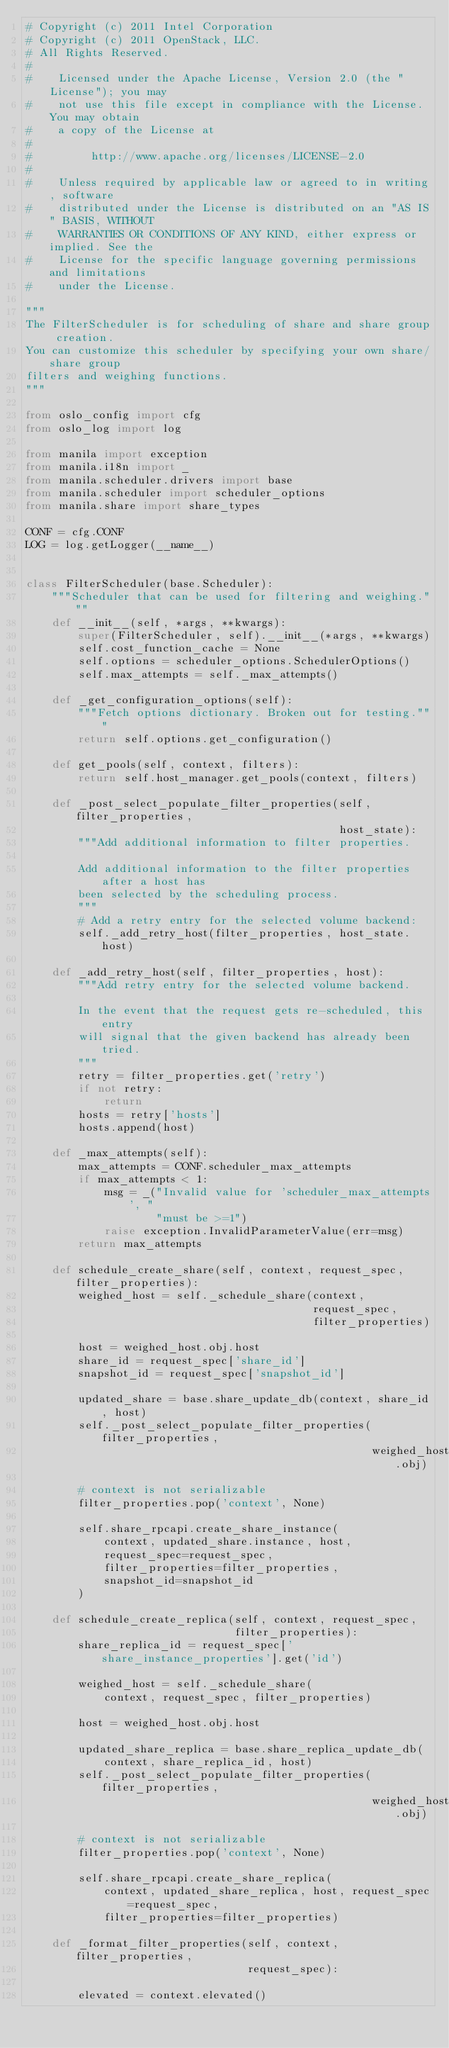Convert code to text. <code><loc_0><loc_0><loc_500><loc_500><_Python_># Copyright (c) 2011 Intel Corporation
# Copyright (c) 2011 OpenStack, LLC.
# All Rights Reserved.
#
#    Licensed under the Apache License, Version 2.0 (the "License"); you may
#    not use this file except in compliance with the License. You may obtain
#    a copy of the License at
#
#         http://www.apache.org/licenses/LICENSE-2.0
#
#    Unless required by applicable law or agreed to in writing, software
#    distributed under the License is distributed on an "AS IS" BASIS, WITHOUT
#    WARRANTIES OR CONDITIONS OF ANY KIND, either express or implied. See the
#    License for the specific language governing permissions and limitations
#    under the License.

"""
The FilterScheduler is for scheduling of share and share group creation.
You can customize this scheduler by specifying your own share/share group
filters and weighing functions.
"""

from oslo_config import cfg
from oslo_log import log

from manila import exception
from manila.i18n import _
from manila.scheduler.drivers import base
from manila.scheduler import scheduler_options
from manila.share import share_types

CONF = cfg.CONF
LOG = log.getLogger(__name__)


class FilterScheduler(base.Scheduler):
    """Scheduler that can be used for filtering and weighing."""
    def __init__(self, *args, **kwargs):
        super(FilterScheduler, self).__init__(*args, **kwargs)
        self.cost_function_cache = None
        self.options = scheduler_options.SchedulerOptions()
        self.max_attempts = self._max_attempts()

    def _get_configuration_options(self):
        """Fetch options dictionary. Broken out for testing."""
        return self.options.get_configuration()

    def get_pools(self, context, filters):
        return self.host_manager.get_pools(context, filters)

    def _post_select_populate_filter_properties(self, filter_properties,
                                                host_state):
        """Add additional information to filter properties.

        Add additional information to the filter properties after a host has
        been selected by the scheduling process.
        """
        # Add a retry entry for the selected volume backend:
        self._add_retry_host(filter_properties, host_state.host)

    def _add_retry_host(self, filter_properties, host):
        """Add retry entry for the selected volume backend.

        In the event that the request gets re-scheduled, this entry
        will signal that the given backend has already been tried.
        """
        retry = filter_properties.get('retry')
        if not retry:
            return
        hosts = retry['hosts']
        hosts.append(host)

    def _max_attempts(self):
        max_attempts = CONF.scheduler_max_attempts
        if max_attempts < 1:
            msg = _("Invalid value for 'scheduler_max_attempts', "
                    "must be >=1")
            raise exception.InvalidParameterValue(err=msg)
        return max_attempts

    def schedule_create_share(self, context, request_spec, filter_properties):
        weighed_host = self._schedule_share(context,
                                            request_spec,
                                            filter_properties)

        host = weighed_host.obj.host
        share_id = request_spec['share_id']
        snapshot_id = request_spec['snapshot_id']

        updated_share = base.share_update_db(context, share_id, host)
        self._post_select_populate_filter_properties(filter_properties,
                                                     weighed_host.obj)

        # context is not serializable
        filter_properties.pop('context', None)

        self.share_rpcapi.create_share_instance(
            context, updated_share.instance, host,
            request_spec=request_spec,
            filter_properties=filter_properties,
            snapshot_id=snapshot_id
        )

    def schedule_create_replica(self, context, request_spec,
                                filter_properties):
        share_replica_id = request_spec['share_instance_properties'].get('id')

        weighed_host = self._schedule_share(
            context, request_spec, filter_properties)

        host = weighed_host.obj.host

        updated_share_replica = base.share_replica_update_db(
            context, share_replica_id, host)
        self._post_select_populate_filter_properties(filter_properties,
                                                     weighed_host.obj)

        # context is not serializable
        filter_properties.pop('context', None)

        self.share_rpcapi.create_share_replica(
            context, updated_share_replica, host, request_spec=request_spec,
            filter_properties=filter_properties)

    def _format_filter_properties(self, context, filter_properties,
                                  request_spec):

        elevated = context.elevated()
</code> 